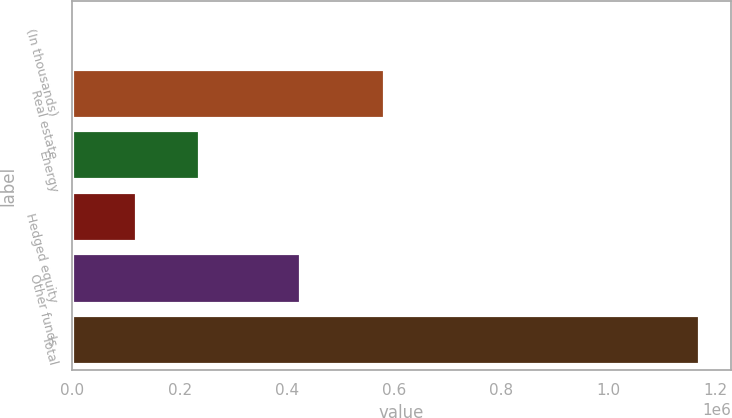Convert chart. <chart><loc_0><loc_0><loc_500><loc_500><bar_chart><fcel>(In thousands)<fcel>Real estate<fcel>Energy<fcel>Hedged equity<fcel>Other funds<fcel>Total<nl><fcel>2015<fcel>580830<fcel>235620<fcel>118818<fcel>424911<fcel>1.17004e+06<nl></chart> 